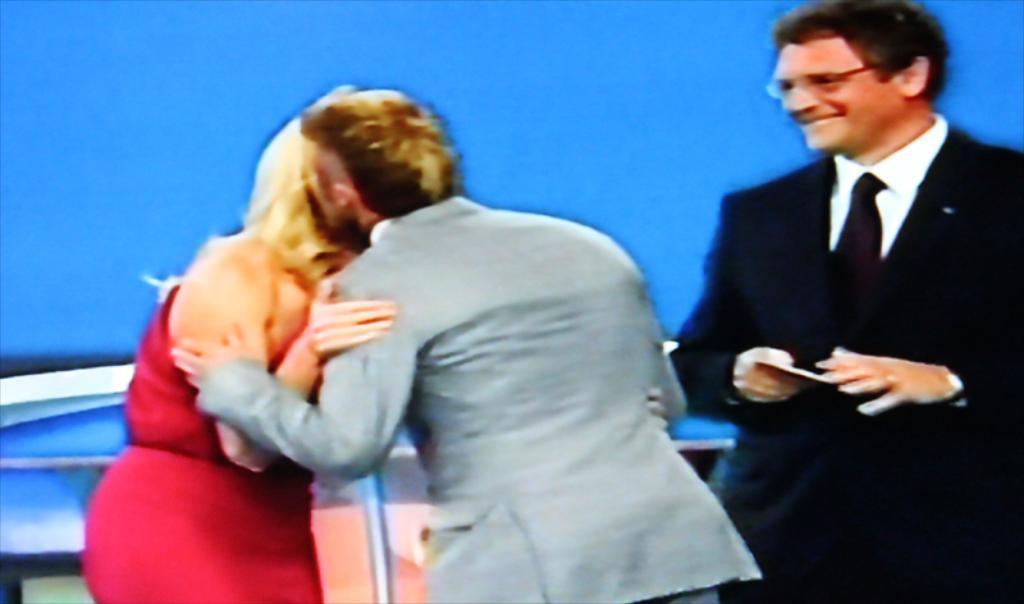In one or two sentences, can you explain what this image depicts? In the image there are two people in the foreground hugging each other and on the right side there is a man standing and smiling, the background of a picture is in blue colour. 